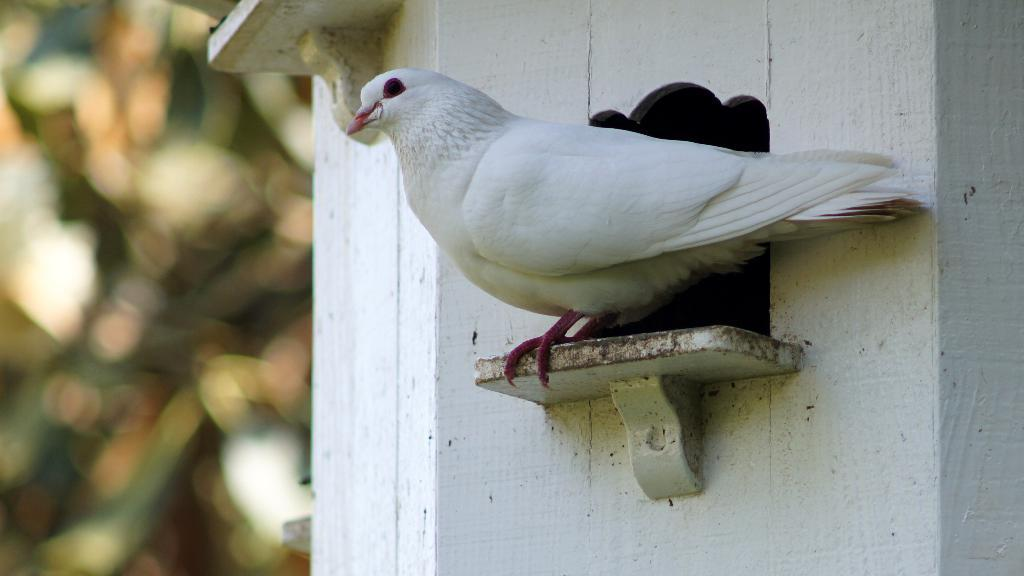What type of bird is in the image? There is a pigeon in the image. Where is the pigeon located? The pigeon is on a birdhouse. Can you describe the background of the image? The background of the image is blurry. What type of machine is the pigeon using to communicate with the kitty in the image? There is no machine or kitty present in the image, and therefore no such interaction can be observed. 